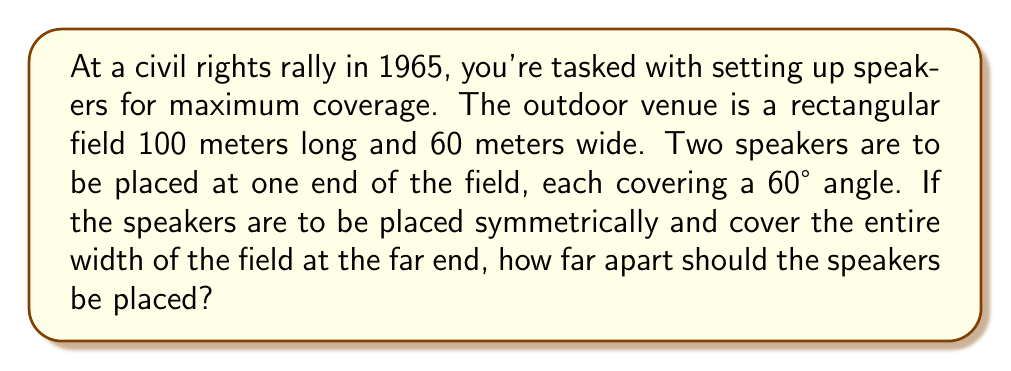Can you answer this question? Let's approach this step-by-step:

1) First, let's visualize the problem:

[asy]
unitsize(2mm);
draw((0,0)--(100,0)--(100,60)--(0,60)--cycle);
draw((0,0)--(100,60));
draw((0,60)--(100,0));
label("100m", (50,-5));
label("60m", (-5,30), W);
label("x", (0,-5));
dot((0,0));
dot((0,60));
[/asy]

2) We can see that this forms two right triangles. We'll focus on one of them.

3) In this right triangle:
   - The opposite side is half the width of the field: 30 meters
   - The adjacent side is the length of the field: 100 meters
   - The angle is half of the speaker's coverage: 30°

4) We need to find the length of the third side of this triangle, which is half the distance between the speakers. Let's call this distance $x/2$.

5) We can use the tangent function to solve this:

   $$\tan(30°) = \frac{30}{100}$$

6) We know that $\tan(30°) = \frac{1}{\sqrt{3}}$, so:

   $$\frac{1}{\sqrt{3}} = \frac{30}{100}$$

7) Cross-multiplying:

   $$100 = 30\sqrt{3}$$

8) This confirms our setup is correct. Now, let's use the tangent function again to find $x/2$:

   $$\tan(30°) = \frac{30}{x/2}$$

9) Substituting $\frac{1}{\sqrt{3}}$ for $\tan(30°)$:

   $$\frac{1}{\sqrt{3}} = \frac{30}{x/2}$$

10) Solving for $x/2$:

    $$x/2 = 30\sqrt{3}$$

11) Therefore, $x = 60\sqrt{3}$ meters.
Answer: $60\sqrt{3}$ meters 